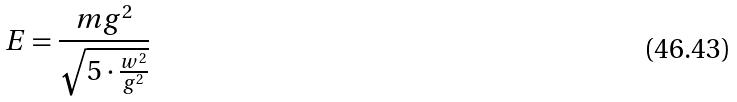Convert formula to latex. <formula><loc_0><loc_0><loc_500><loc_500>E = \frac { m g ^ { 2 } } { \sqrt { 5 \cdot \frac { w ^ { 2 } } { g ^ { 2 } } } }</formula> 